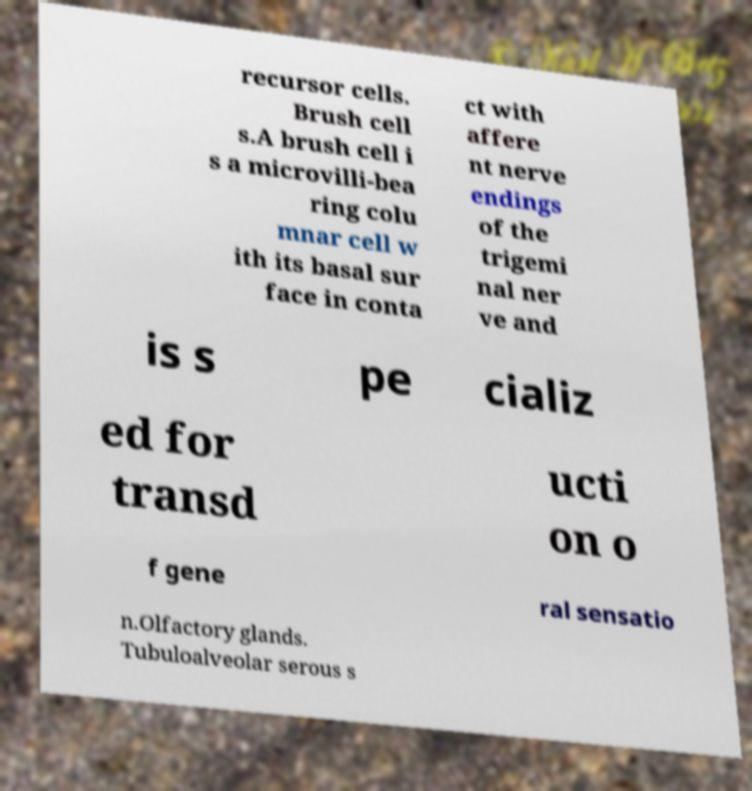Could you extract and type out the text from this image? recursor cells. Brush cell s.A brush cell i s a microvilli-bea ring colu mnar cell w ith its basal sur face in conta ct with affere nt nerve endings of the trigemi nal ner ve and is s pe cializ ed for transd ucti on o f gene ral sensatio n.Olfactory glands. Tubuloalveolar serous s 